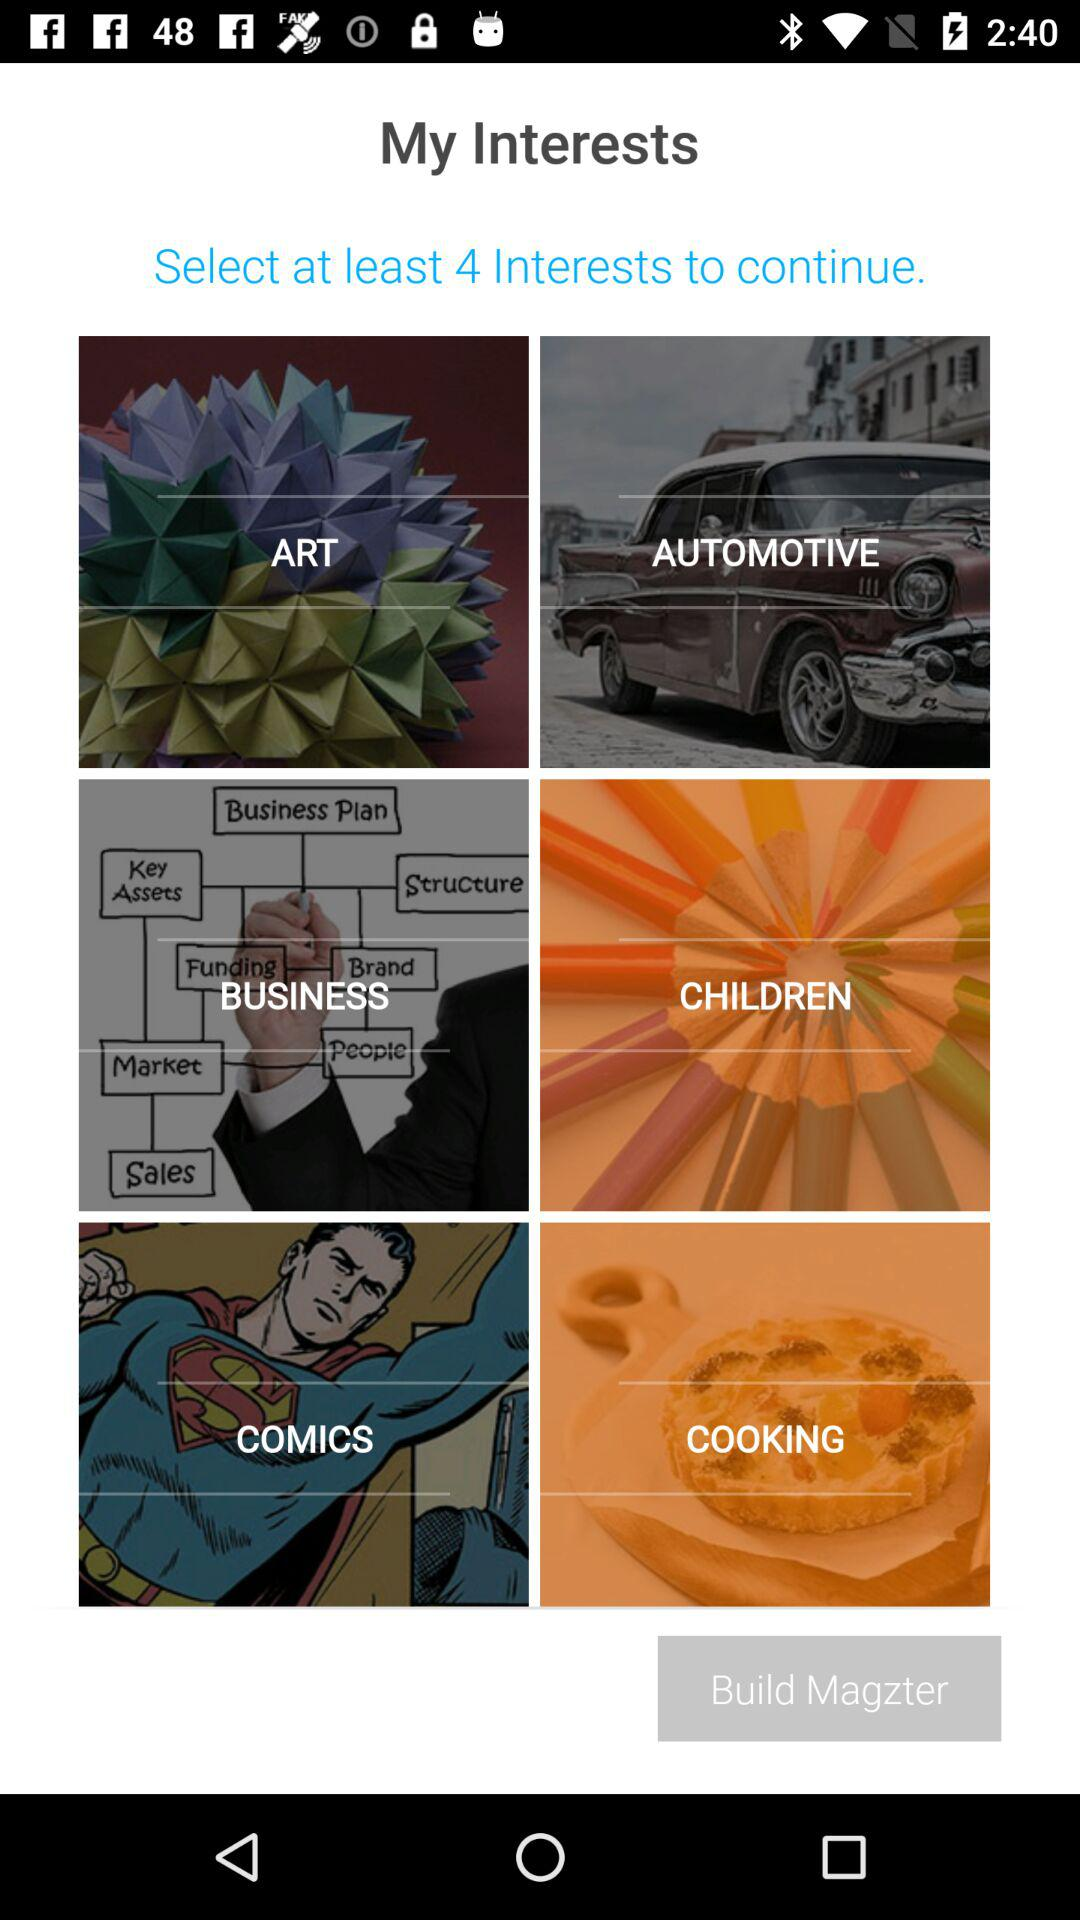To continue, at least how many interests must be selected? To continue, at least 4 interests must be selected. 